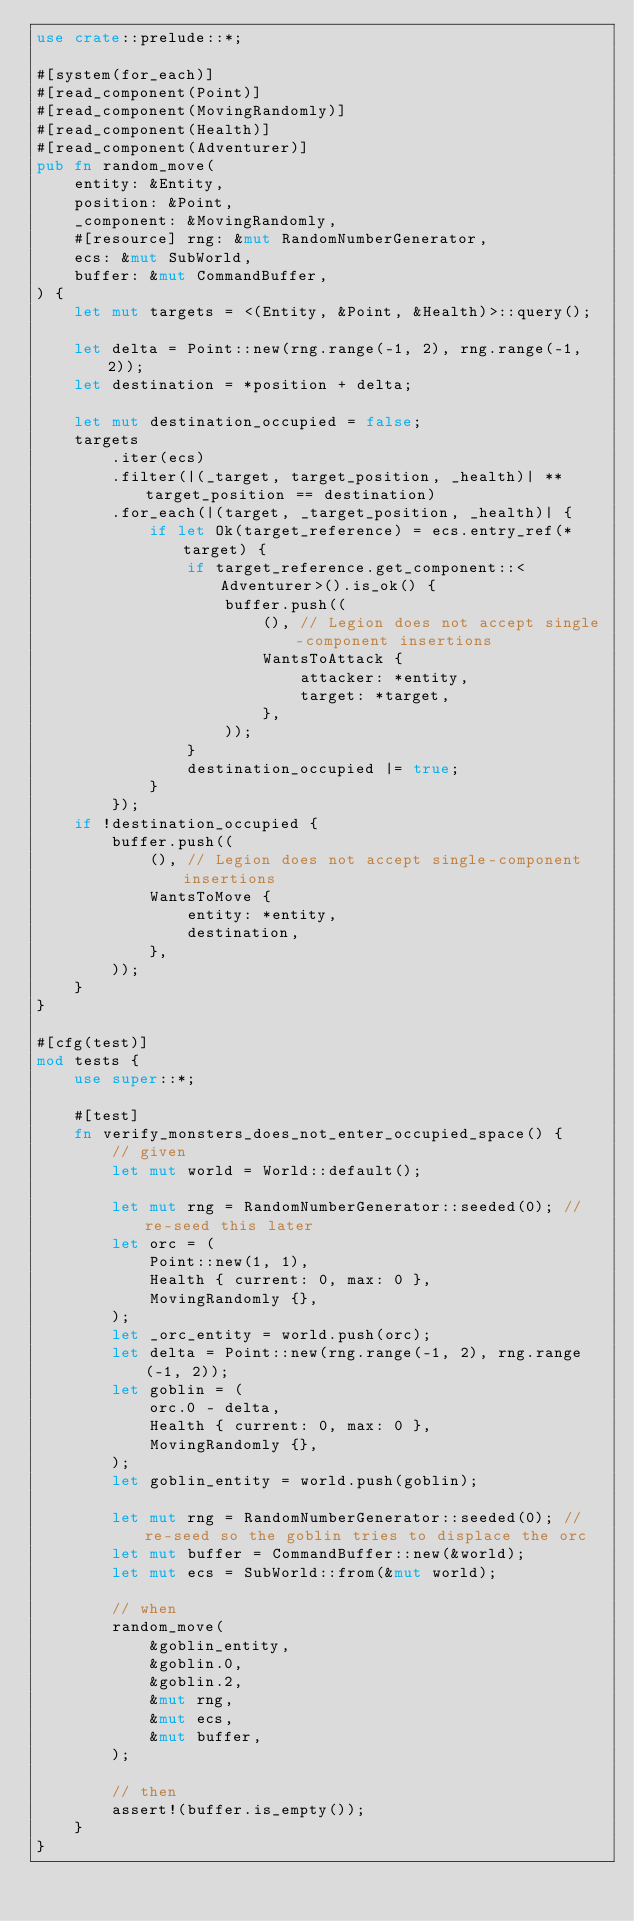Convert code to text. <code><loc_0><loc_0><loc_500><loc_500><_Rust_>use crate::prelude::*;

#[system(for_each)]
#[read_component(Point)]
#[read_component(MovingRandomly)]
#[read_component(Health)]
#[read_component(Adventurer)]
pub fn random_move(
    entity: &Entity,
    position: &Point,
    _component: &MovingRandomly,
    #[resource] rng: &mut RandomNumberGenerator,
    ecs: &mut SubWorld,
    buffer: &mut CommandBuffer,
) {
    let mut targets = <(Entity, &Point, &Health)>::query();

    let delta = Point::new(rng.range(-1, 2), rng.range(-1, 2));
    let destination = *position + delta;

    let mut destination_occupied = false;
    targets
        .iter(ecs)
        .filter(|(_target, target_position, _health)| **target_position == destination)
        .for_each(|(target, _target_position, _health)| {
            if let Ok(target_reference) = ecs.entry_ref(*target) {
                if target_reference.get_component::<Adventurer>().is_ok() {
                    buffer.push((
                        (), // Legion does not accept single-component insertions
                        WantsToAttack {
                            attacker: *entity,
                            target: *target,
                        },
                    ));
                }
                destination_occupied |= true;
            }
        });
    if !destination_occupied {
        buffer.push((
            (), // Legion does not accept single-component insertions
            WantsToMove {
                entity: *entity,
                destination,
            },
        ));
    }
}

#[cfg(test)]
mod tests {
    use super::*;

    #[test]
    fn verify_monsters_does_not_enter_occupied_space() {
        // given
        let mut world = World::default();

        let mut rng = RandomNumberGenerator::seeded(0); // re-seed this later
        let orc = (
            Point::new(1, 1),
            Health { current: 0, max: 0 },
            MovingRandomly {},
        );
        let _orc_entity = world.push(orc);
        let delta = Point::new(rng.range(-1, 2), rng.range(-1, 2));
        let goblin = (
            orc.0 - delta,
            Health { current: 0, max: 0 },
            MovingRandomly {},
        );
        let goblin_entity = world.push(goblin);

        let mut rng = RandomNumberGenerator::seeded(0); // re-seed so the goblin tries to displace the orc
        let mut buffer = CommandBuffer::new(&world);
        let mut ecs = SubWorld::from(&mut world);

        // when
        random_move(
            &goblin_entity,
            &goblin.0,
            &goblin.2,
            &mut rng,
            &mut ecs,
            &mut buffer,
        );

        // then
        assert!(buffer.is_empty());
    }
}
</code> 